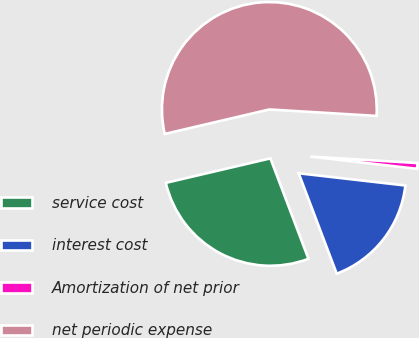<chart> <loc_0><loc_0><loc_500><loc_500><pie_chart><fcel>service cost<fcel>interest cost<fcel>Amortization of net prior<fcel>net periodic expense<nl><fcel>27.1%<fcel>17.42%<fcel>0.86%<fcel>54.62%<nl></chart> 